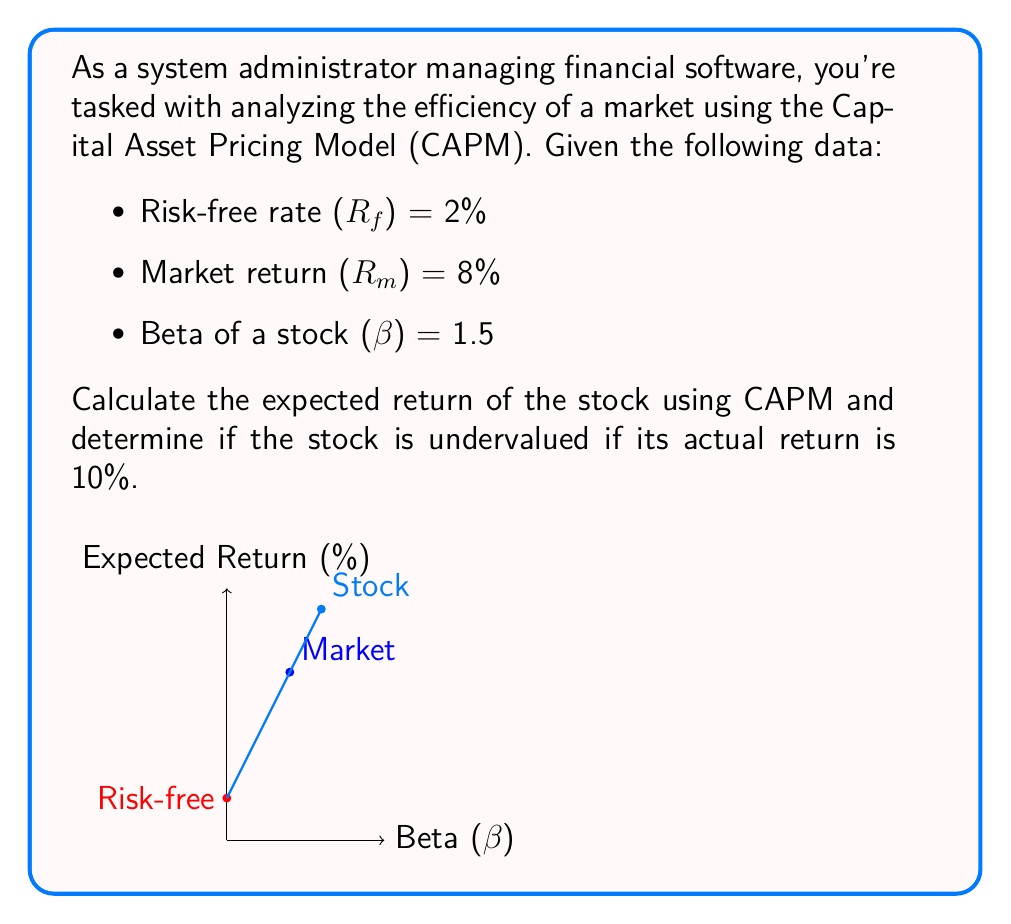Show me your answer to this math problem. To analyze the efficiency of the market using CAPM and determine if the stock is undervalued, we'll follow these steps:

1) First, recall the CAPM formula:

   $$ E(R_i) = R_f + \beta_i(R_m - R_f) $$

   Where:
   $E(R_i)$ is the expected return of the stock
   $R_f$ is the risk-free rate
   $\beta_i$ is the beta of the stock
   $R_m$ is the market return

2) Plug in the given values:

   $$ E(R_i) = 2\% + 1.5(8\% - 2\%) $$

3) Simplify:

   $$ E(R_i) = 2\% + 1.5(6\%) $$
   $$ E(R_i) = 2\% + 9\% $$
   $$ E(R_i) = 11\% $$

4) Compare the expected return (11%) with the actual return (10%):

   Since the actual return (10%) is less than the expected return (11%), the stock is overvalued according to CAPM.

5) Interpret the result:

   In an efficient market, the stock's price should adjust until its expected return matches the CAPM prediction. In this case, the stock price should decrease to increase its expected return to 11%.
Answer: Expected return = 11%; Stock is overvalued 